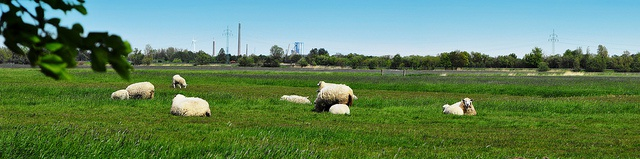Describe the objects in this image and their specific colors. I can see sheep in black, beige, khaki, and tan tones, sheep in black, beige, and tan tones, sheep in black, beige, and tan tones, sheep in black, ivory, beige, tan, and darkgray tones, and sheep in black, beige, darkgray, and darkgreen tones in this image. 